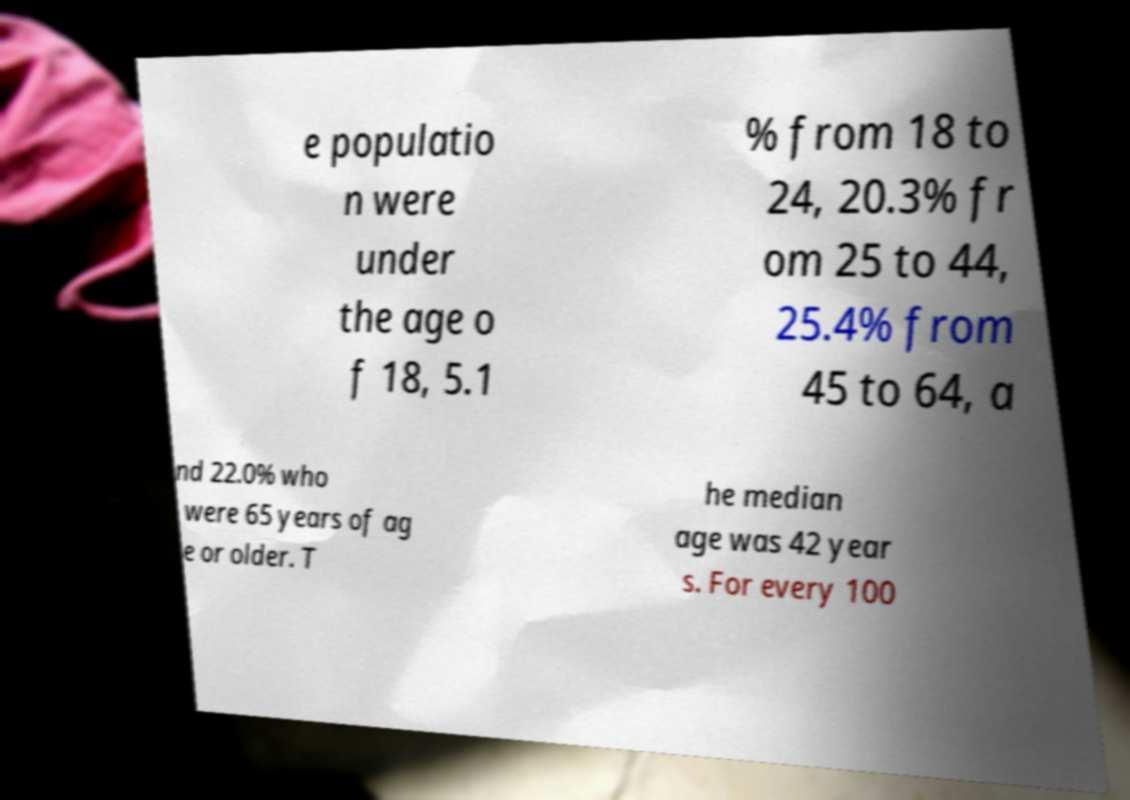What messages or text are displayed in this image? I need them in a readable, typed format. e populatio n were under the age o f 18, 5.1 % from 18 to 24, 20.3% fr om 25 to 44, 25.4% from 45 to 64, a nd 22.0% who were 65 years of ag e or older. T he median age was 42 year s. For every 100 